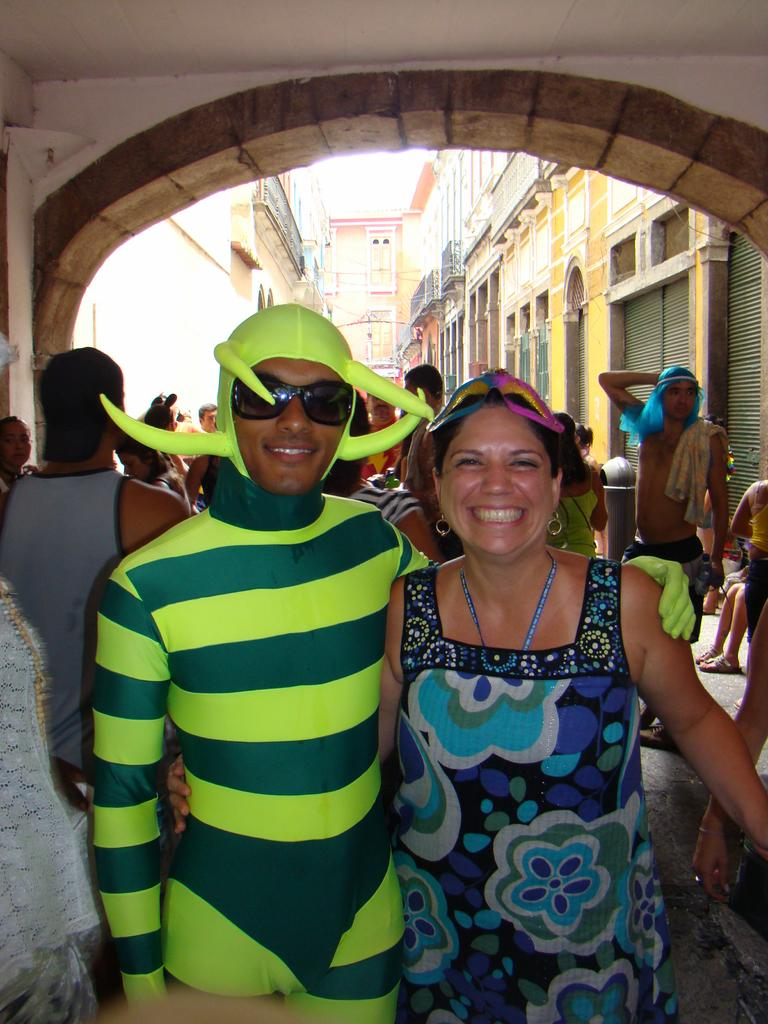How many people are present in the image? There are people in the image, but the exact number is not specified. What is unique about the appearance of one person in the image? One person is wearing a costume. What can be seen in the distance behind the people? There are buildings in the background of the image. What is visible above the buildings and people? The sky is visible in the background of the image. What type of bone can be seen in the image? There is no bone present in the image. How does the brain of the person in the costume function in the image? There is no indication of the person's brain function in the image, as it is not visible or mentioned. 